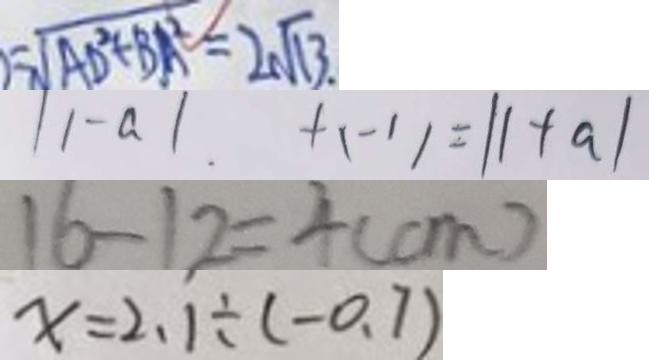Convert formula to latex. <formula><loc_0><loc_0><loc_500><loc_500>= \sqrt { A D ^ { 2 } + B A ^ { 2 } } = 2 \sqrt { 1 3 } \cdot 
 \vert 1 - a \vert + ( - 1 ) = \vert 1 + a \vert 
 1 6 - 1 2 = 4 ( c m ) 
 x = 2 . 1 \div ( - 0 . 7 )</formula> 